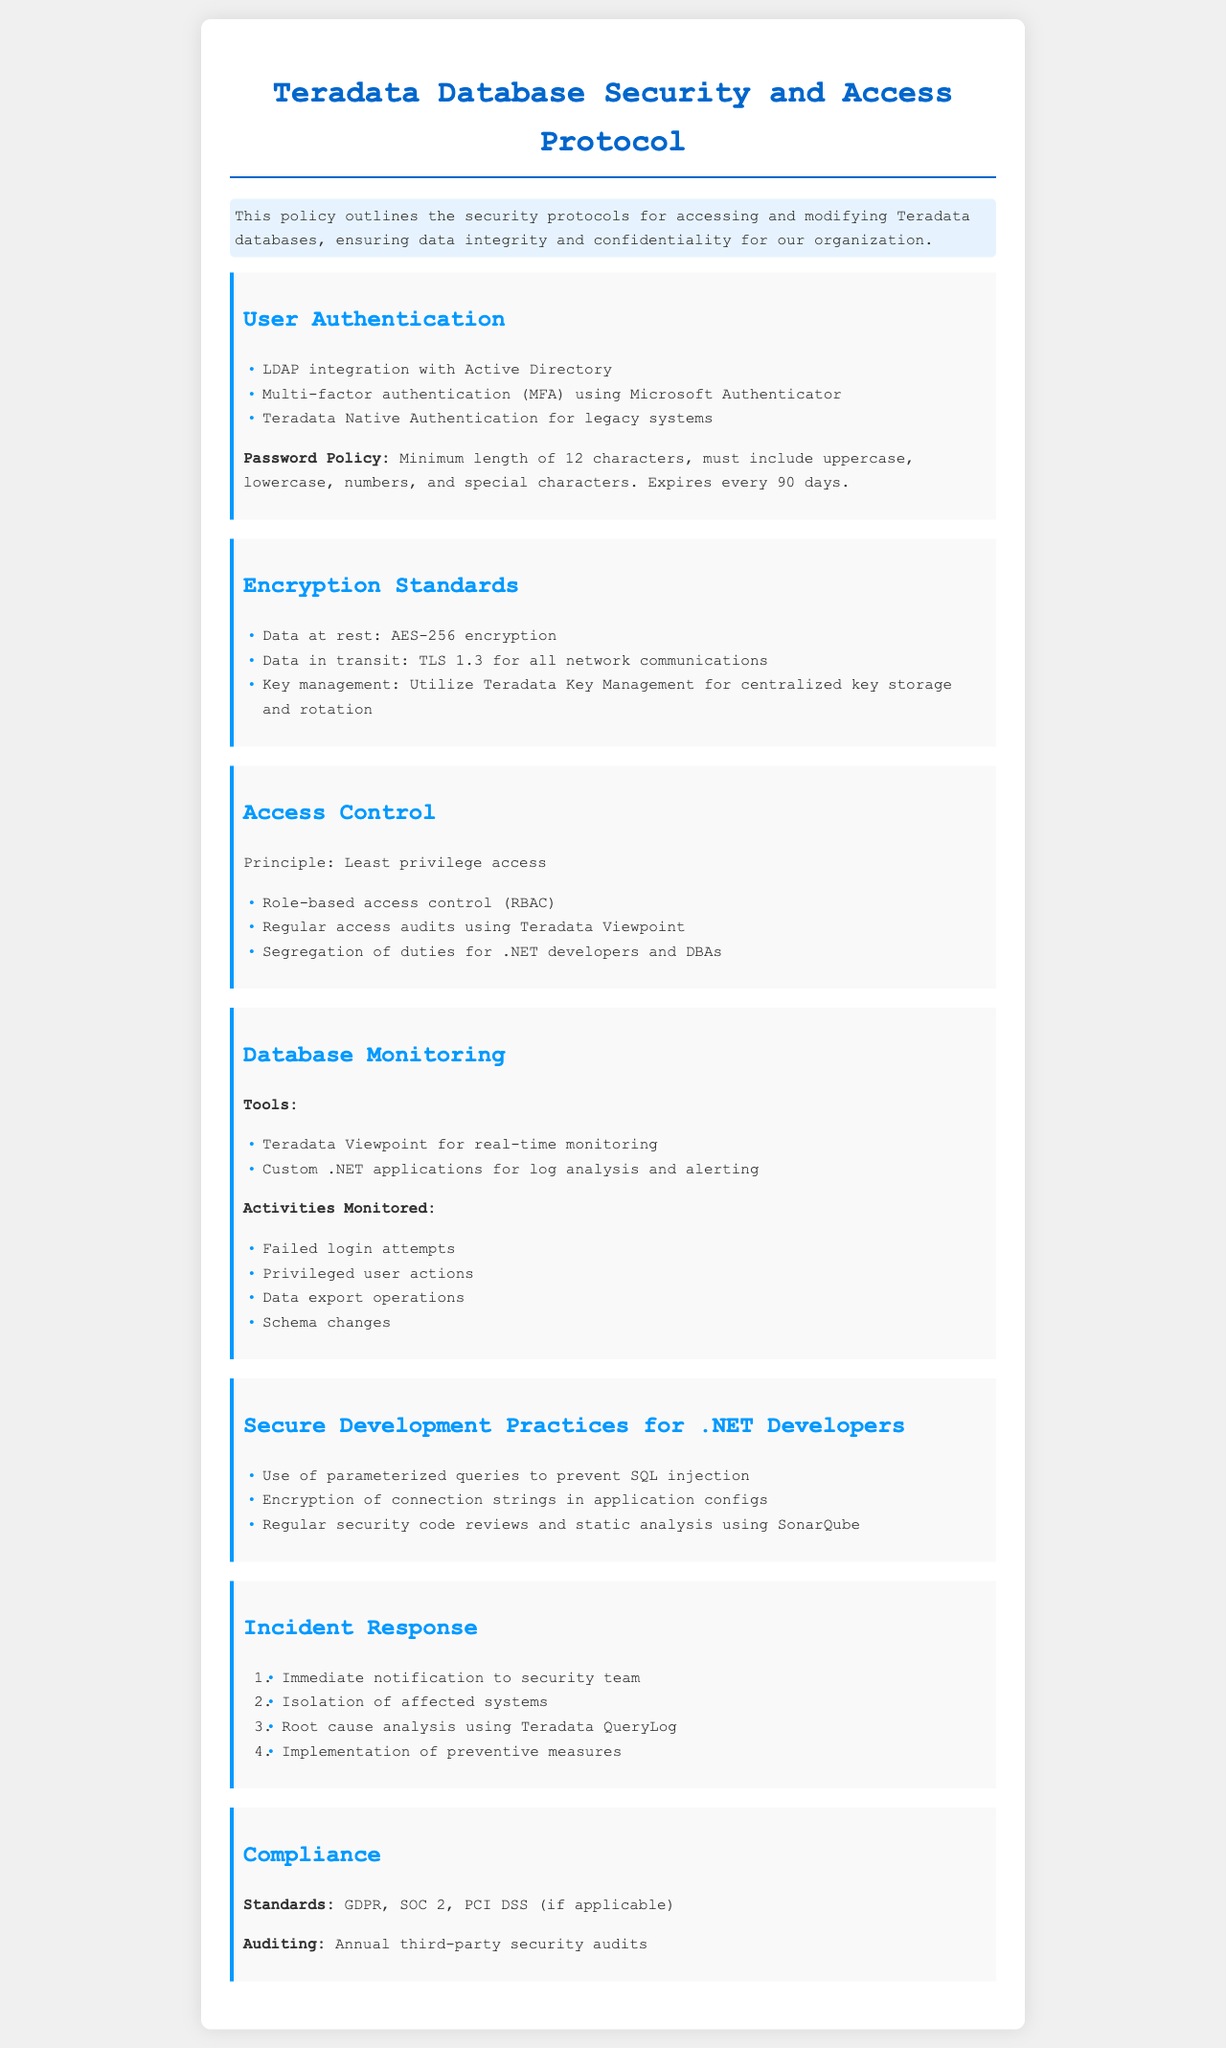What is the minimum password length? The document states that the minimum password length is specified in the password policy section.
Answer: 12 characters What type of encryption is used for data at rest? The document specifies the encryption standard for data at rest in the encryption standards section.
Answer: AES-256 What is the principle of access control mentioned? The principle of access control is clearly stated in the access control section of the document.
Answer: Least privilege access Which tool is mentioned for real-time database monitoring? The document lists the tools used for database monitoring, including one specific tool for real-time use.
Answer: Teradata Viewpoint How often do passwords expire? The document explains the frequency at which passwords are set to expire according to the password policy.
Answer: 90 days What authentication method is used for legacy systems? The document outlines a specific authentication method applicable to legacy systems under the user authentication section.
Answer: Teradata Native Authentication What encryption protocol is required for data in transit? The document provides details on the encryption protocols for data in transit in the encryption standards section.
Answer: TLS 1.3 What is the first step in the incident response process? The document describes the incident response process and lists the initial action in response to an incident.
Answer: Immediate notification to security team 